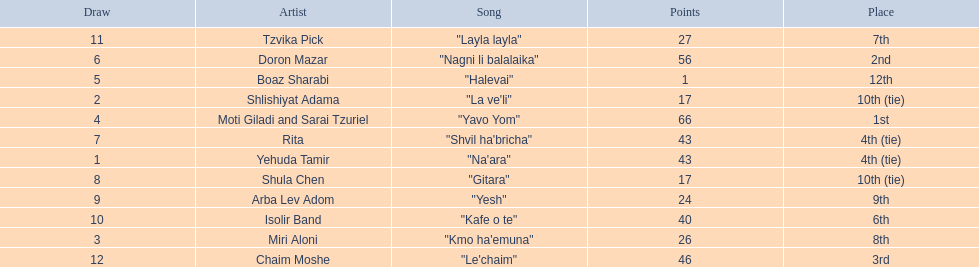Who are all of the artists? Yehuda Tamir, Shlishiyat Adama, Miri Aloni, Moti Giladi and Sarai Tzuriel, Boaz Sharabi, Doron Mazar, Rita, Shula Chen, Arba Lev Adom, Isolir Band, Tzvika Pick, Chaim Moshe. How many points did each score? 43, 17, 26, 66, 1, 56, 43, 17, 24, 40, 27, 46. And which artist had the least amount of points? Boaz Sharabi. 